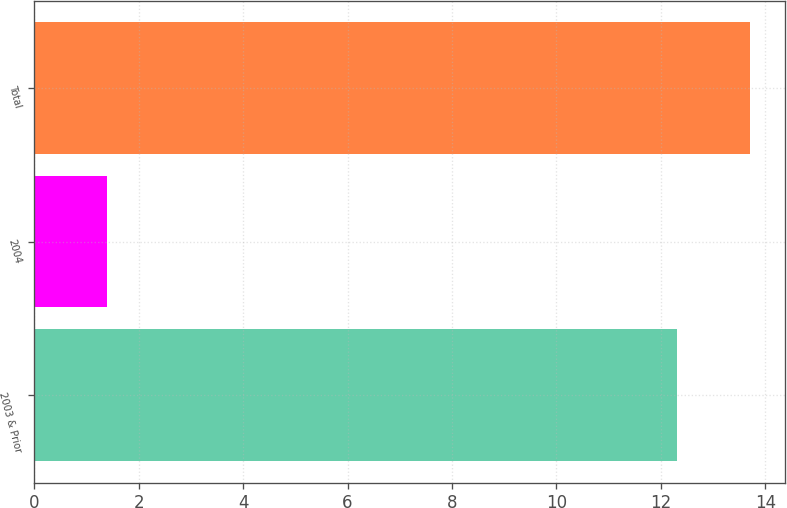<chart> <loc_0><loc_0><loc_500><loc_500><bar_chart><fcel>2003 & Prior<fcel>2004<fcel>Total<nl><fcel>12.3<fcel>1.4<fcel>13.7<nl></chart> 